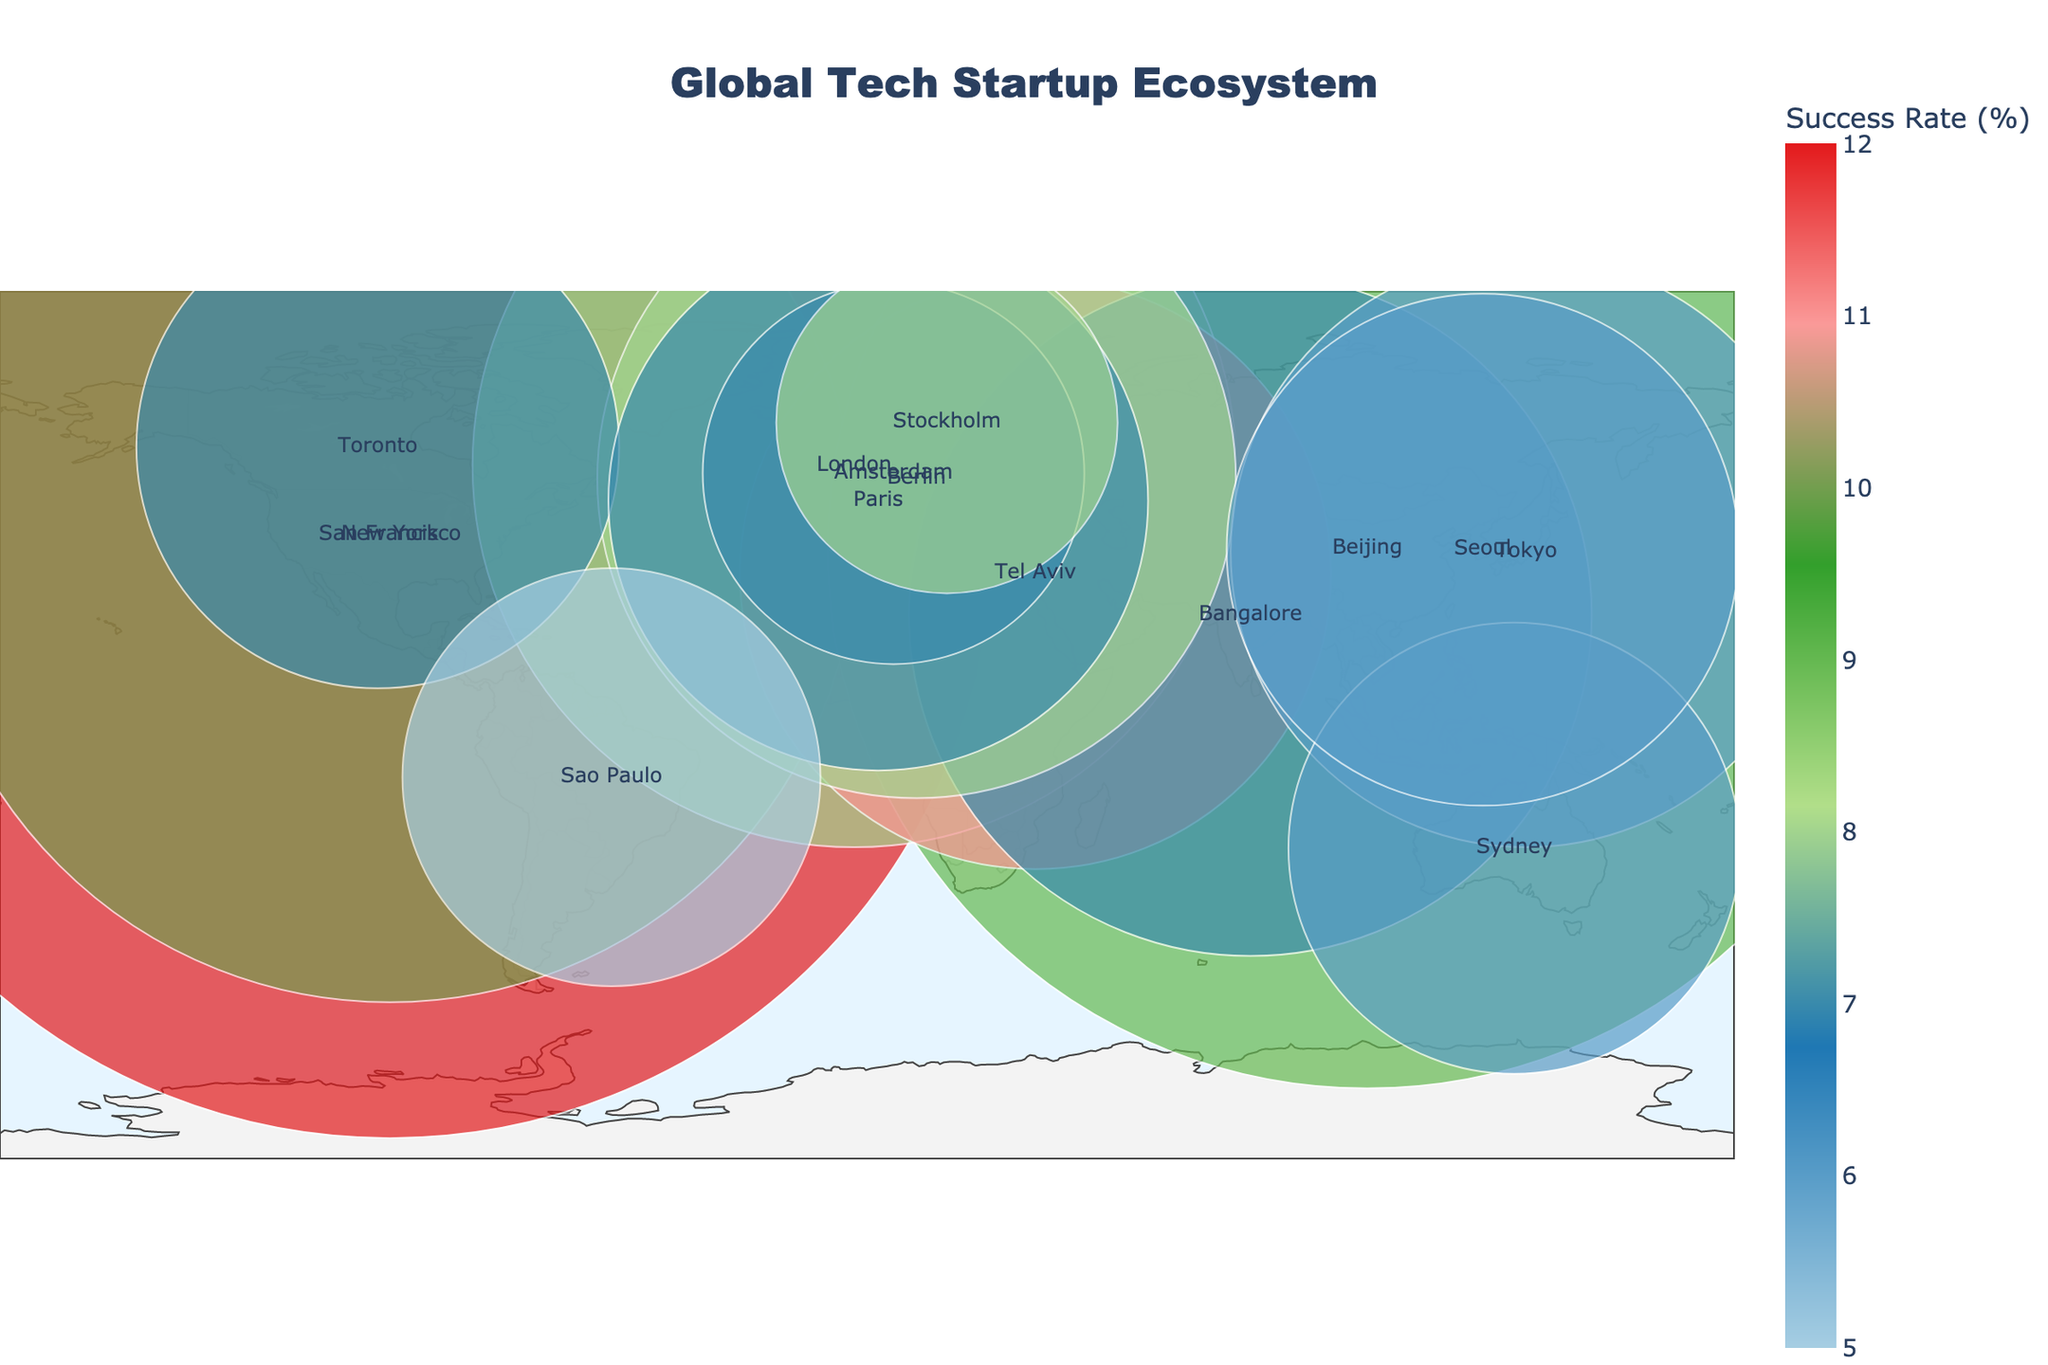What is the title of the plot? The title of the plot is located at the top and is formatted with large, bold text to be easily recognizable.
Answer: Global Tech Startup Ecosystem Which city has the highest success rate for startups? To find this, look for the city with the highest value on the color scale, which represents the success rate. Hovering over or checking the color legend can help identify it.
Answer: San Francisco How many startups are there in Berlin? Berlin's details can be found by locating the city on the map and observing the data provided in its hover information.
Answer: 1800 What is the funding level for startups in Tel Aviv? Look for Tel Aviv on the map, and the funding level in millions will be shown in the hover information or by observing the size of the marker.
Answer: $6000 million Compare the number of startups in San Francisco to those in New York. Which has more, and by how much? Identify the number of startups for both cities from their respective data points on the map. San Francisco has 5000 startups, and New York has 3500. Subtract New York's startups from San Francisco's to find the difference.
Answer: San Francisco, by 1500 startups Which city has the smallest number of startups and what is its Tech Focus? Look for the smallest markers on the map as they represent the number of startups. Hovering over or checking for the smallest data point can help identify this.
Answer: Amsterdam, AgTech What is the average success rate of tech ecosystems in this plot? First, list all success rates from the data: 12, 10, 9, 8, 11, 7, 8, 9, 7, 6, 7, 5, 6, 7, 8, 6. Sum these values and divide by the total number of data points, which is 16. Calculation: (12+10+9+8+11+7+8+9+7+6+7+5+6+7+8+6)/16
Answer: 7.75% How does the funding level of AI & Machine Learning startups in San Francisco compare to those in Toronto? Identify the funding levels for both cities: San Francisco has $25000 million and Toronto has $4000 million. Subtract Toronto's funding from San Francisco's to find the difference.
Answer: San Francisco is higher by $21000 million Which country, outside of the United States, has the highest funding level in total? Sum the funding levels of cities within each country outside of the United States and compare these sums. China has Beijing with $20000 million, which is higher than other countries listed.
Answer: China Is there a correlation between the number of startups and the success rate in major tech ecosystems? To examine this, look for a pattern in the sizes of the markers (number of startups) and their color intensity (success rate). In the plot, although there are variations, a clear direct correlation is not visually apparent as both San Francisco (high startups, high rate) and San Paulo (low startups, low rate) indicate.
Answer: No clear correlation 